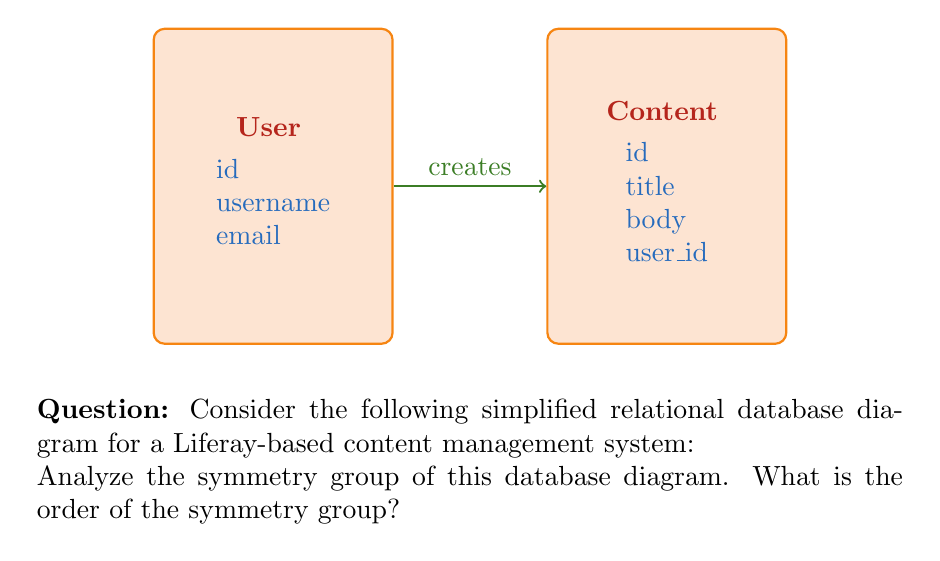Help me with this question. To analyze the symmetry group of this relational database diagram, we need to consider all possible transformations that preserve the structure of the diagram. Let's approach this step-by-step:

1) First, let's identify the elements of the diagram:
   - Two tables: User and Content
   - A relationship (arrow) from User to Content

2) Now, let's consider possible symmetries:

   a) Rotation: The diagram cannot be rotated 180 degrees without changing its appearance, as the arrow direction would change. So rotational symmetry is not present.

   b) Reflection: There is no axis of reflection that would preserve the structure of the diagram. A vertical reflection would reverse the arrow direction, and a horizontal reflection would swap the tables, changing their relative positions.

   c) Translation: Moving the entire diagram doesn't change its structure, but this is not considered a symmetry in this context as we're looking at the internal symmetries of the diagram.

   d) Identity: The trivial transformation that leaves everything unchanged is always a symmetry.

3) Therefore, the only symmetry operation that preserves the structure of this diagram is the identity transformation.

4) In group theory, we define the symmetry group as the set of all symmetry operations. In this case, the symmetry group contains only one element: the identity operation.

5) The order of a group is the number of elements in the group. Since our symmetry group contains only the identity element, its order is 1.

This type of group with only one element is known as the trivial group or identity group, often denoted as $C_1$ or $\{e\}$ where $e$ represents the identity element.
Answer: 1 